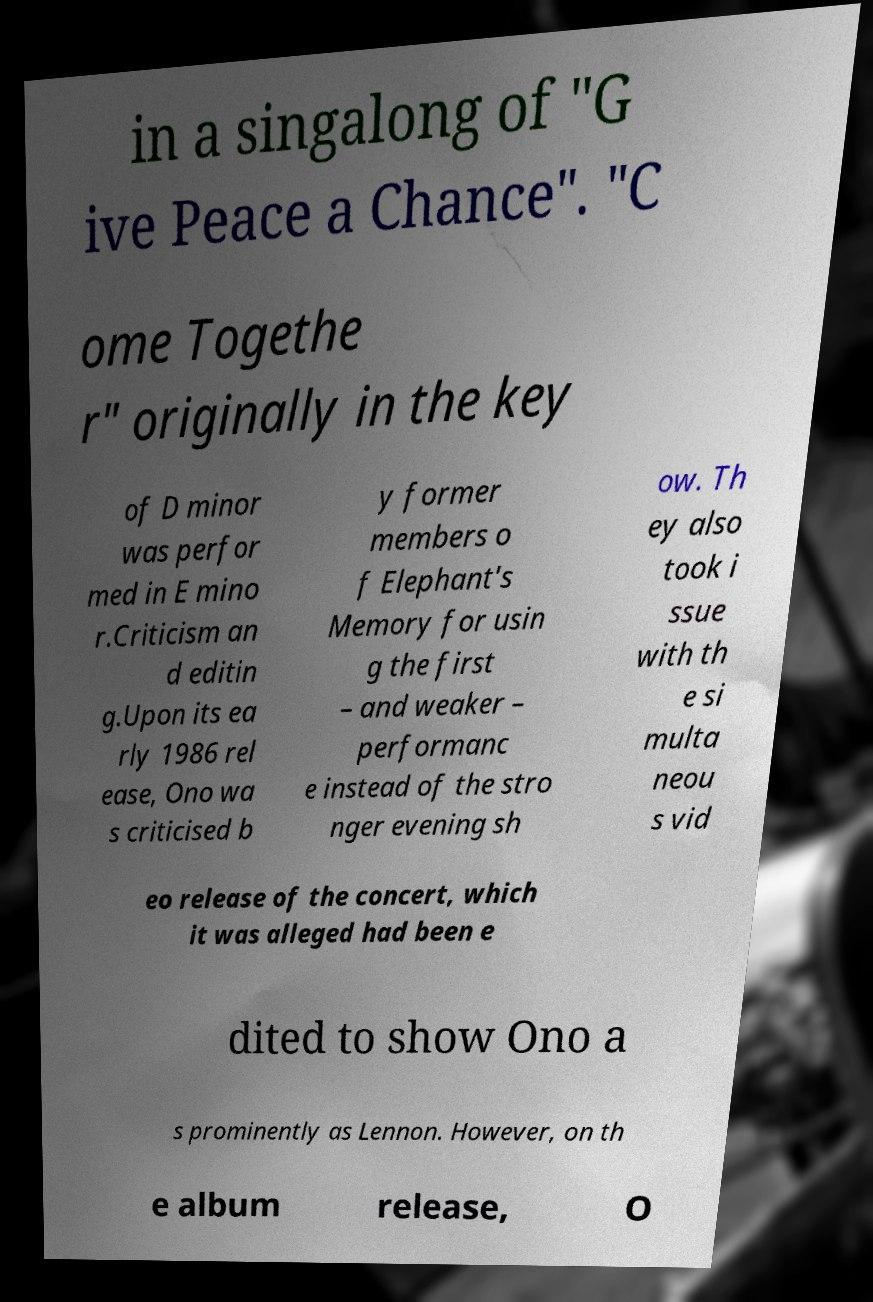Could you extract and type out the text from this image? in a singalong of "G ive Peace a Chance". "C ome Togethe r" originally in the key of D minor was perfor med in E mino r.Criticism an d editin g.Upon its ea rly 1986 rel ease, Ono wa s criticised b y former members o f Elephant's Memory for usin g the first – and weaker – performanc e instead of the stro nger evening sh ow. Th ey also took i ssue with th e si multa neou s vid eo release of the concert, which it was alleged had been e dited to show Ono a s prominently as Lennon. However, on th e album release, O 